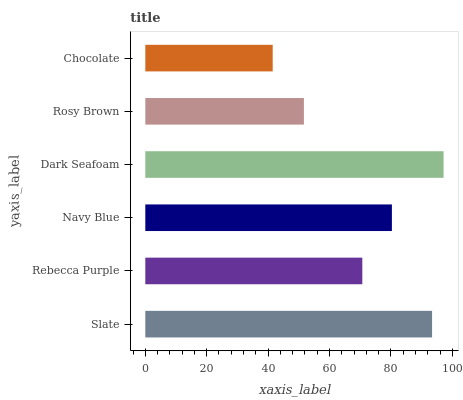Is Chocolate the minimum?
Answer yes or no. Yes. Is Dark Seafoam the maximum?
Answer yes or no. Yes. Is Rebecca Purple the minimum?
Answer yes or no. No. Is Rebecca Purple the maximum?
Answer yes or no. No. Is Slate greater than Rebecca Purple?
Answer yes or no. Yes. Is Rebecca Purple less than Slate?
Answer yes or no. Yes. Is Rebecca Purple greater than Slate?
Answer yes or no. No. Is Slate less than Rebecca Purple?
Answer yes or no. No. Is Navy Blue the high median?
Answer yes or no. Yes. Is Rebecca Purple the low median?
Answer yes or no. Yes. Is Rebecca Purple the high median?
Answer yes or no. No. Is Rosy Brown the low median?
Answer yes or no. No. 